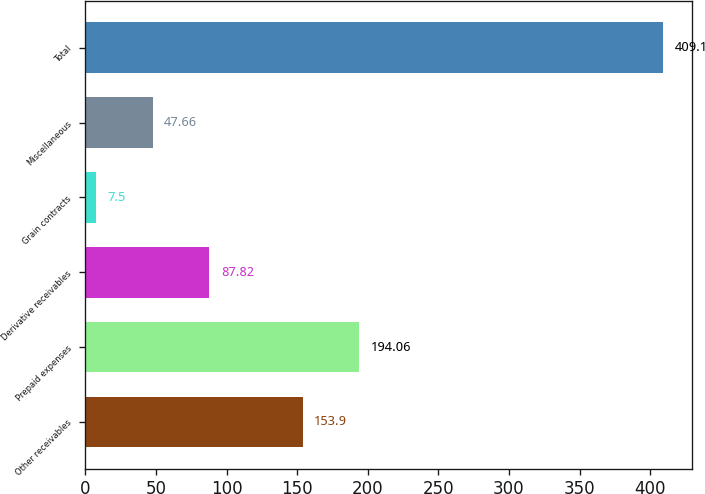Convert chart. <chart><loc_0><loc_0><loc_500><loc_500><bar_chart><fcel>Other receivables<fcel>Prepaid expenses<fcel>Derivative receivables<fcel>Grain contracts<fcel>Miscellaneous<fcel>Total<nl><fcel>153.9<fcel>194.06<fcel>87.82<fcel>7.5<fcel>47.66<fcel>409.1<nl></chart> 